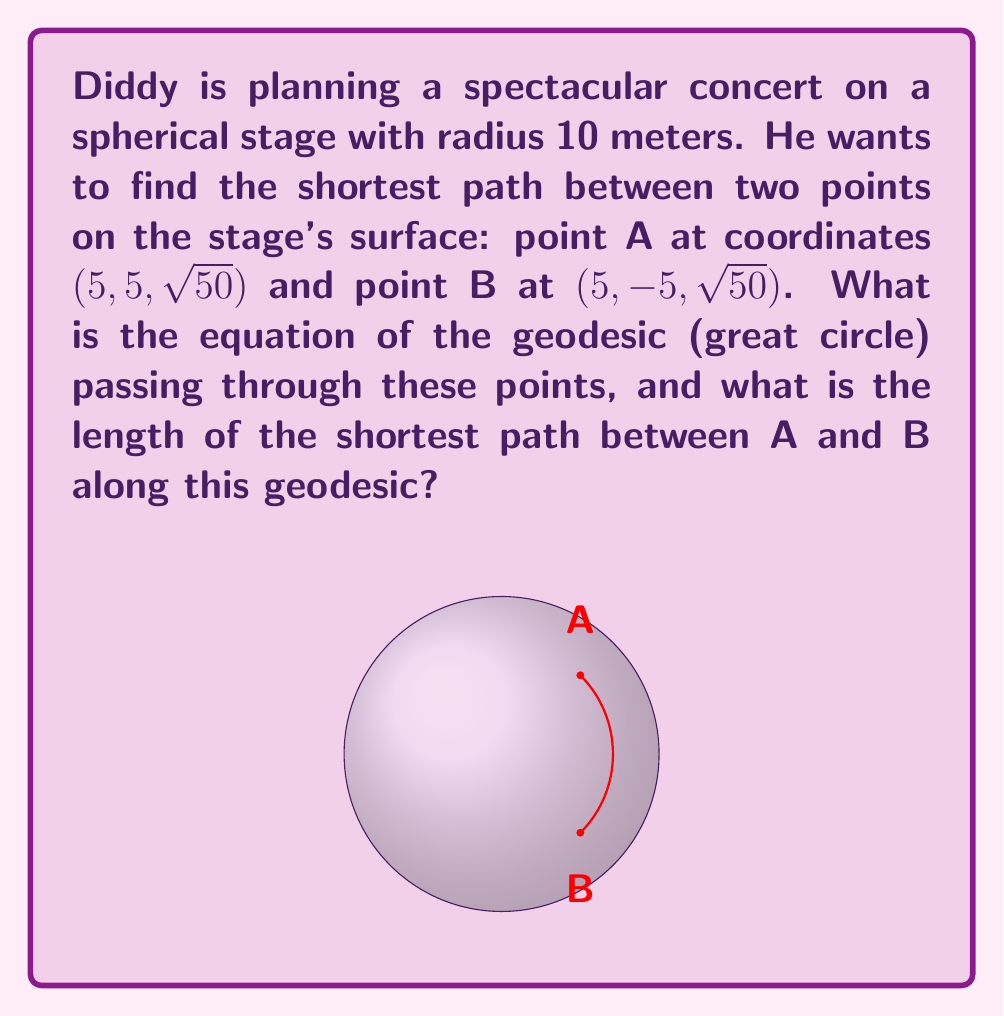Could you help me with this problem? Let's approach this step-by-step:

1) First, recall that geodesics on a sphere are great circles, which are intersections of the sphere with planes passing through its center.

2) The equation of the sphere is:
   $$x^2 + y^2 + z^2 = R^2 = 100$$

3) The general equation of a plane passing through the center (0,0,0) and both points A and B is:
   $$ax + by + cz = 0$$
   where (a,b,c) is normal to the plane.

4) We can find (a,b,c) by taking the cross product of vectors OA and OB:
   $$\vec{OA} = (5, 5, \sqrt{50})$$
   $$\vec{OB} = (5, -5, \sqrt{50})$$
   $$\vec{OA} \times \vec{OB} = (10\sqrt{50}, 0, -50)$$

5) Simplifying and normalizing this vector:
   $$\vec{n} = (2\sqrt{2}, 0, -\sqrt{10})$$

6) Therefore, the equation of the plane is:
   $$2\sqrt{2}x + 0y - \sqrt{10}z = 0$$
   Simplifying: $$2\sqrt{2}x = \sqrt{10}z$$

7) The geodesic is the intersection of this plane with the sphere. So, the parametric equations are:
   $$x = 5\cos(t)$$
   $$y = 5\sin(t)$$
   $$z = \sqrt{50}$$
   where $0 \leq t < 2\pi$

8) To find the length of the path, we need to find the central angle $\theta$ between OA and OB:
   $$\cos(\theta) = \frac{\vec{OA} \cdot \vec{OB}}{|\vec{OA}||\vec{OB}|} = \frac{50}{100} = \frac{1}{2}$$
   $$\theta = \arccos(\frac{1}{2}) = \frac{\pi}{3}$$

9) The length of the arc is:
   $$s = R\theta = 10 \cdot \frac{\pi}{3} = \frac{10\pi}{3}$$
Answer: Geodesic equation: $x = 5\cos(t)$, $y = 5\sin(t)$, $z = \sqrt{50}$ where $0 \leq t < 2\pi$. Path length: $\frac{10\pi}{3}$ meters. 